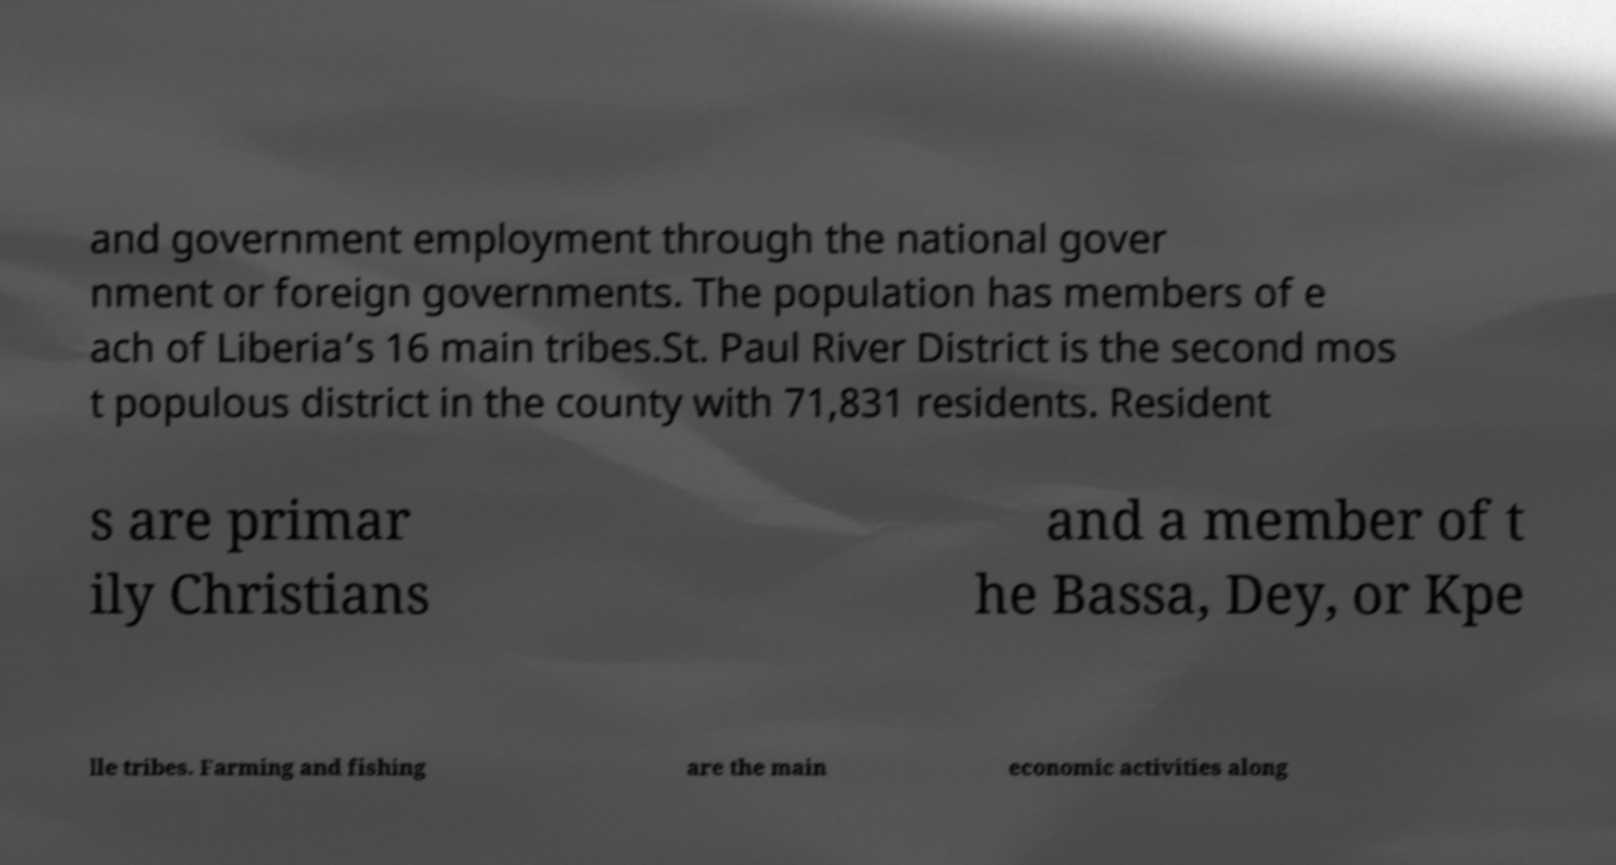Please read and relay the text visible in this image. What does it say? and government employment through the national gover nment or foreign governments. The population has members of e ach of Liberia’s 16 main tribes.St. Paul River District is the second mos t populous district in the county with 71,831 residents. Resident s are primar ily Christians and a member of t he Bassa, Dey, or Kpe lle tribes. Farming and fishing are the main economic activities along 